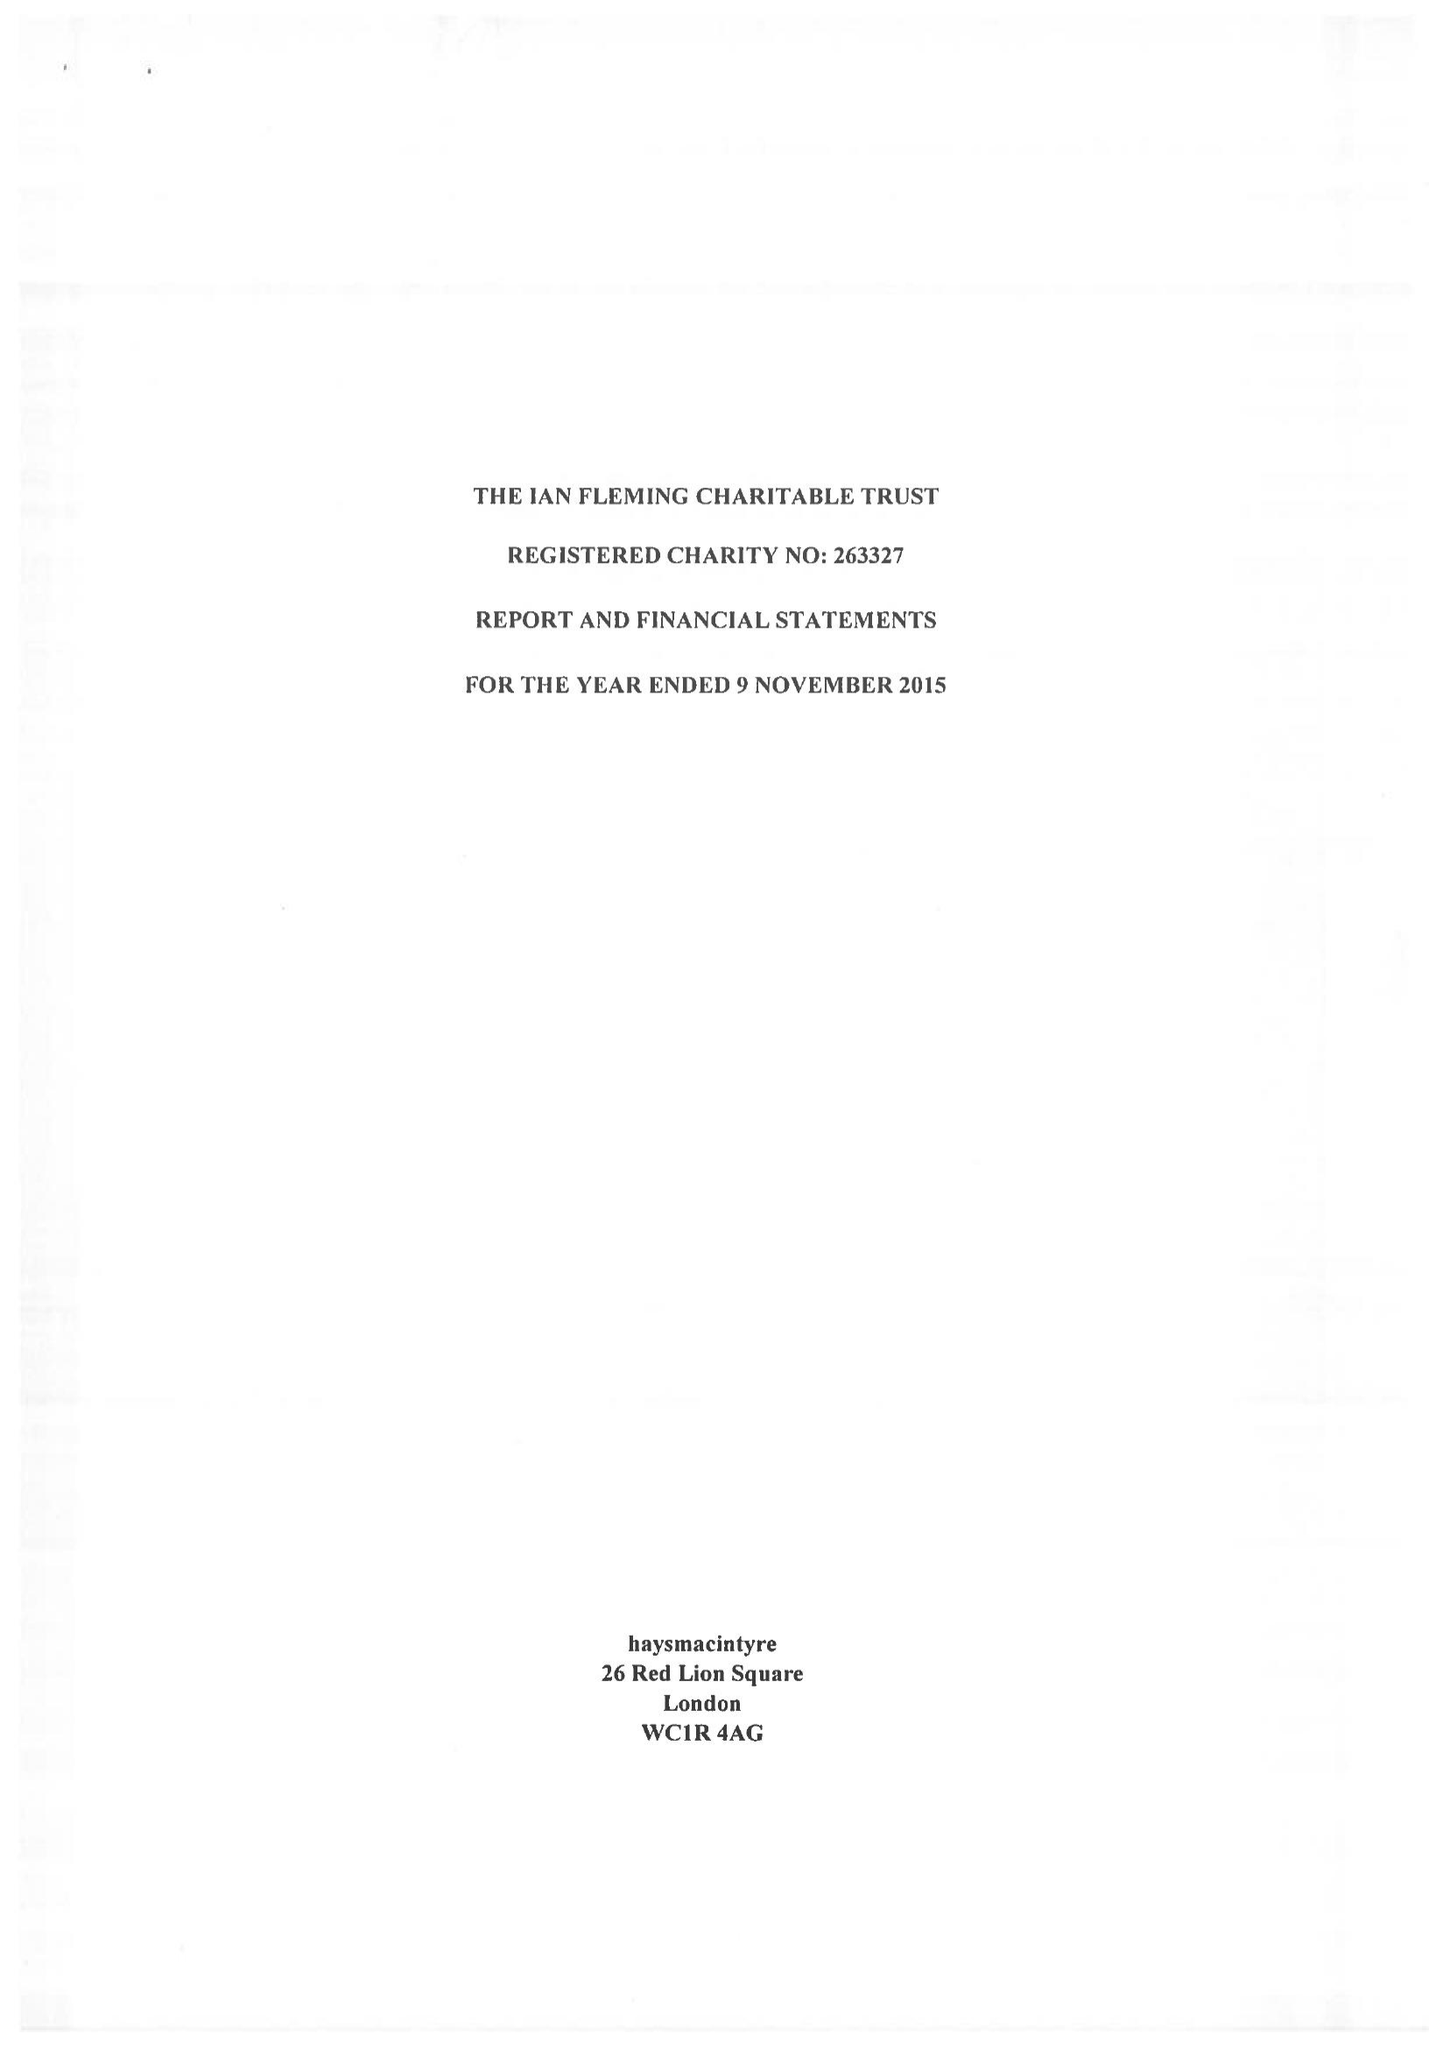What is the value for the address__street_line?
Answer the question using a single word or phrase. 10 QUEEN STREET PLACE 